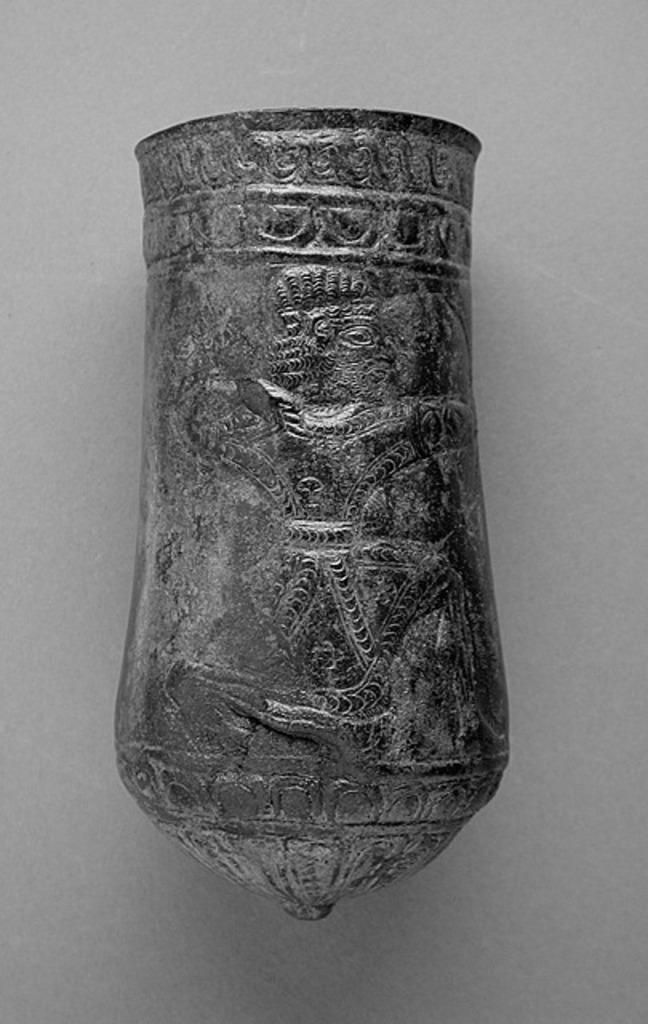What can be seen on the surface in the image? There is an object on the surface in the image. How many bananas are floating in the water near the object in the image? There are no bananas or water present in the image; it only shows an object on a surface. 